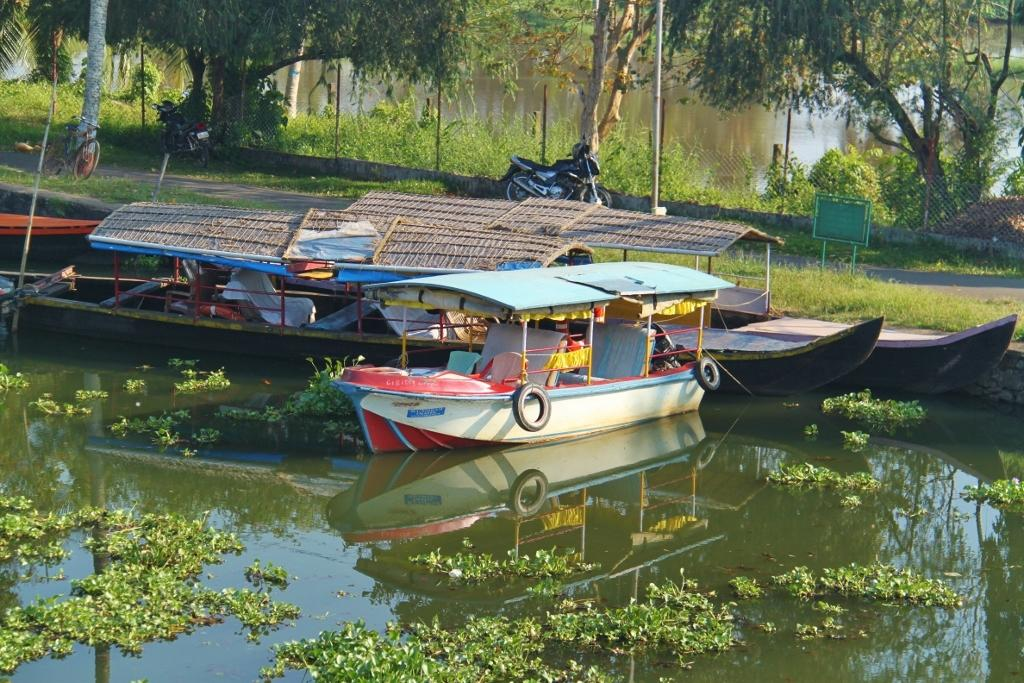What is happening on the water in the image? There are boats on the water in the image. What is happening on the road in the image? There are vehicles on the road in the image. What type of barrier can be seen in the image? There is a fence in the image. What can be seen in the background of the image? There are plants and trees in the background of the image. What idea is being expressed by the mist in the image? There is no mist present in the image, so no idea can be expressed by it. How does the motion of the boats affect the vehicles on the road? The boats and vehicles are not interacting in the image, so their motions do not affect each other. 